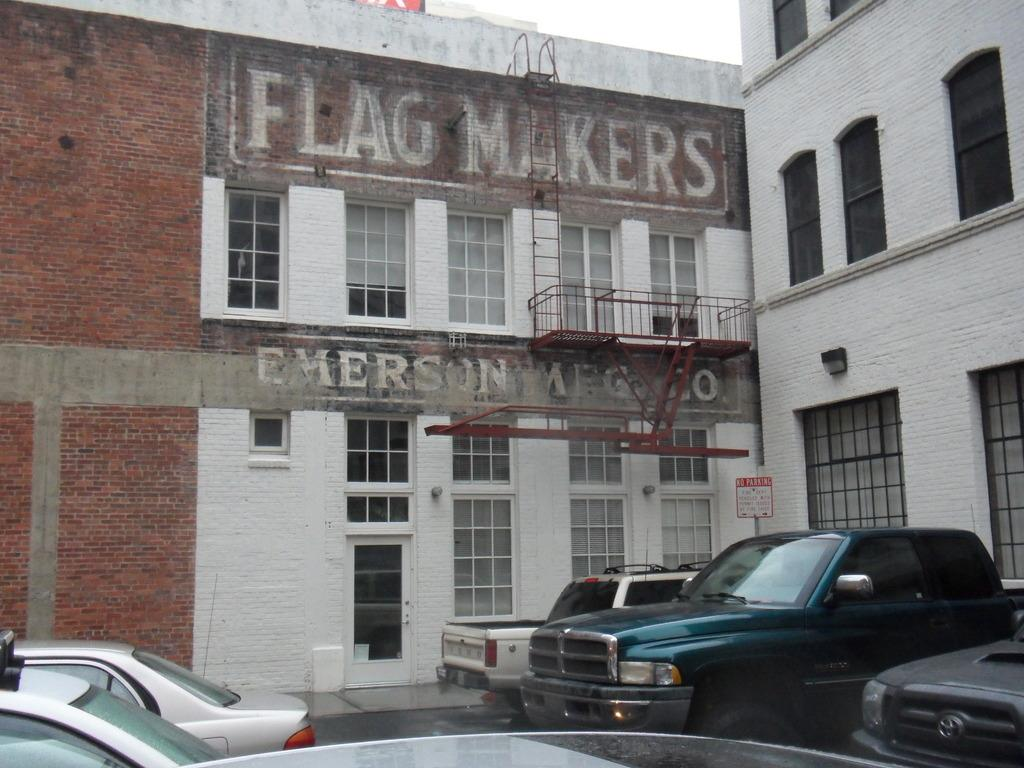What type of structures can be seen in the image? There are buildings in the image. Is there any text or writing visible in the image? Yes, there is text or writing visible in the image. What object can be used for climbing in the image? There is a ladder in the image. What type of vehicles are present in the image? There are cars in the image. How many cups can be seen on the ladder in the image? There are no cups present in the image, and the ladder is not associated with any cups. What color is the nose of the person in the image? There is no person present in the image, and therefore no nose to describe. 